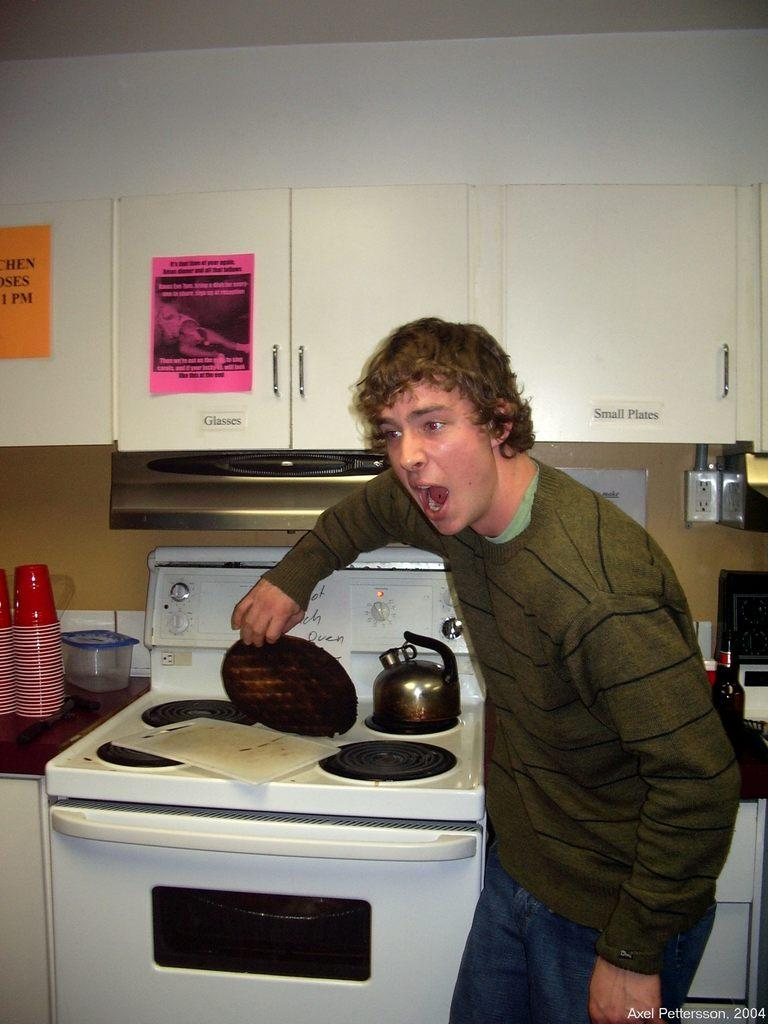<image>
Render a clear and concise summary of the photo. A teen burns his waffle, and the cupboards above his head indicate where to find glasses and small plates. 